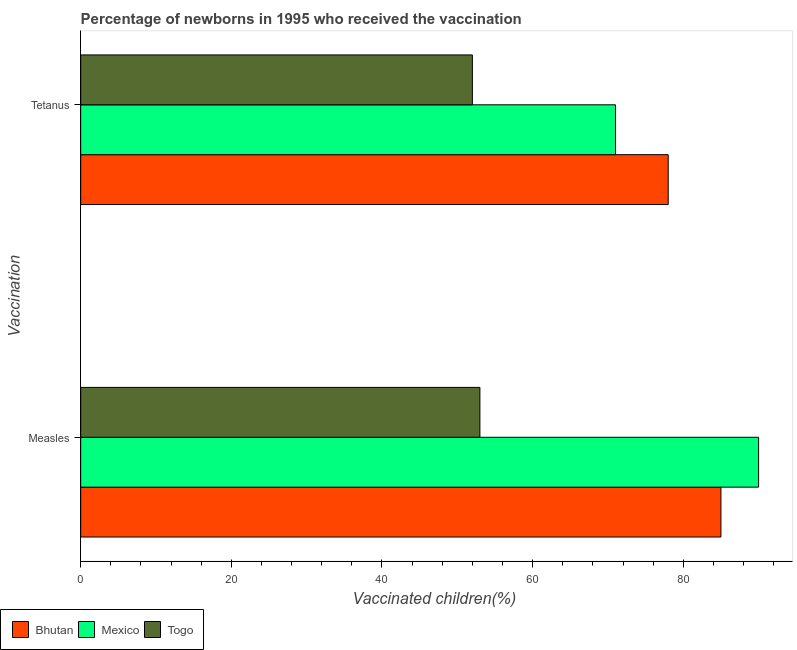How many different coloured bars are there?
Keep it short and to the point. 3. How many groups of bars are there?
Offer a terse response. 2. Are the number of bars on each tick of the Y-axis equal?
Your answer should be compact. Yes. How many bars are there on the 2nd tick from the top?
Your answer should be compact. 3. How many bars are there on the 2nd tick from the bottom?
Keep it short and to the point. 3. What is the label of the 2nd group of bars from the top?
Make the answer very short. Measles. What is the percentage of newborns who received vaccination for tetanus in Bhutan?
Give a very brief answer. 78. Across all countries, what is the maximum percentage of newborns who received vaccination for tetanus?
Ensure brevity in your answer.  78. Across all countries, what is the minimum percentage of newborns who received vaccination for tetanus?
Your answer should be compact. 52. In which country was the percentage of newborns who received vaccination for tetanus maximum?
Provide a short and direct response. Bhutan. In which country was the percentage of newborns who received vaccination for tetanus minimum?
Offer a very short reply. Togo. What is the total percentage of newborns who received vaccination for tetanus in the graph?
Offer a very short reply. 201. What is the difference between the percentage of newborns who received vaccination for measles in Mexico and that in Bhutan?
Offer a very short reply. 5. What is the difference between the percentage of newborns who received vaccination for tetanus in Togo and the percentage of newborns who received vaccination for measles in Mexico?
Provide a succinct answer. -38. What is the difference between the percentage of newborns who received vaccination for tetanus and percentage of newborns who received vaccination for measles in Mexico?
Ensure brevity in your answer.  -19. What is the ratio of the percentage of newborns who received vaccination for tetanus in Bhutan to that in Mexico?
Offer a very short reply. 1.1. Is the percentage of newborns who received vaccination for tetanus in Mexico less than that in Bhutan?
Provide a short and direct response. Yes. What does the 1st bar from the top in Tetanus represents?
Offer a very short reply. Togo. What does the 3rd bar from the bottom in Tetanus represents?
Offer a very short reply. Togo. How many bars are there?
Your answer should be compact. 6. Where does the legend appear in the graph?
Provide a succinct answer. Bottom left. What is the title of the graph?
Provide a short and direct response. Percentage of newborns in 1995 who received the vaccination. Does "Honduras" appear as one of the legend labels in the graph?
Your response must be concise. No. What is the label or title of the X-axis?
Your answer should be very brief. Vaccinated children(%)
. What is the label or title of the Y-axis?
Your answer should be compact. Vaccination. What is the Vaccinated children(%)
 of Mexico in Measles?
Provide a short and direct response. 90. Across all Vaccination, what is the maximum Vaccinated children(%)
 in Togo?
Offer a very short reply. 53. Across all Vaccination, what is the minimum Vaccinated children(%)
 in Mexico?
Give a very brief answer. 71. What is the total Vaccinated children(%)
 in Bhutan in the graph?
Provide a succinct answer. 163. What is the total Vaccinated children(%)
 in Mexico in the graph?
Keep it short and to the point. 161. What is the total Vaccinated children(%)
 in Togo in the graph?
Keep it short and to the point. 105. What is the difference between the Vaccinated children(%)
 of Bhutan in Measles and that in Tetanus?
Offer a terse response. 7. What is the difference between the Vaccinated children(%)
 of Mexico in Measles and that in Tetanus?
Your answer should be very brief. 19. What is the difference between the Vaccinated children(%)
 in Togo in Measles and that in Tetanus?
Your answer should be compact. 1. What is the difference between the Vaccinated children(%)
 in Bhutan in Measles and the Vaccinated children(%)
 in Mexico in Tetanus?
Offer a terse response. 14. What is the difference between the Vaccinated children(%)
 in Bhutan in Measles and the Vaccinated children(%)
 in Togo in Tetanus?
Offer a terse response. 33. What is the difference between the Vaccinated children(%)
 in Mexico in Measles and the Vaccinated children(%)
 in Togo in Tetanus?
Provide a succinct answer. 38. What is the average Vaccinated children(%)
 of Bhutan per Vaccination?
Your response must be concise. 81.5. What is the average Vaccinated children(%)
 of Mexico per Vaccination?
Provide a short and direct response. 80.5. What is the average Vaccinated children(%)
 of Togo per Vaccination?
Make the answer very short. 52.5. What is the difference between the Vaccinated children(%)
 in Bhutan and Vaccinated children(%)
 in Mexico in Measles?
Make the answer very short. -5. What is the difference between the Vaccinated children(%)
 of Mexico and Vaccinated children(%)
 of Togo in Measles?
Offer a very short reply. 37. What is the difference between the Vaccinated children(%)
 in Bhutan and Vaccinated children(%)
 in Mexico in Tetanus?
Your answer should be compact. 7. What is the difference between the Vaccinated children(%)
 of Bhutan and Vaccinated children(%)
 of Togo in Tetanus?
Make the answer very short. 26. What is the difference between the Vaccinated children(%)
 in Mexico and Vaccinated children(%)
 in Togo in Tetanus?
Your answer should be compact. 19. What is the ratio of the Vaccinated children(%)
 in Bhutan in Measles to that in Tetanus?
Keep it short and to the point. 1.09. What is the ratio of the Vaccinated children(%)
 of Mexico in Measles to that in Tetanus?
Your answer should be compact. 1.27. What is the ratio of the Vaccinated children(%)
 in Togo in Measles to that in Tetanus?
Ensure brevity in your answer.  1.02. What is the difference between the highest and the second highest Vaccinated children(%)
 in Bhutan?
Keep it short and to the point. 7. What is the difference between the highest and the second highest Vaccinated children(%)
 in Togo?
Offer a terse response. 1. What is the difference between the highest and the lowest Vaccinated children(%)
 in Mexico?
Make the answer very short. 19. What is the difference between the highest and the lowest Vaccinated children(%)
 of Togo?
Offer a terse response. 1. 